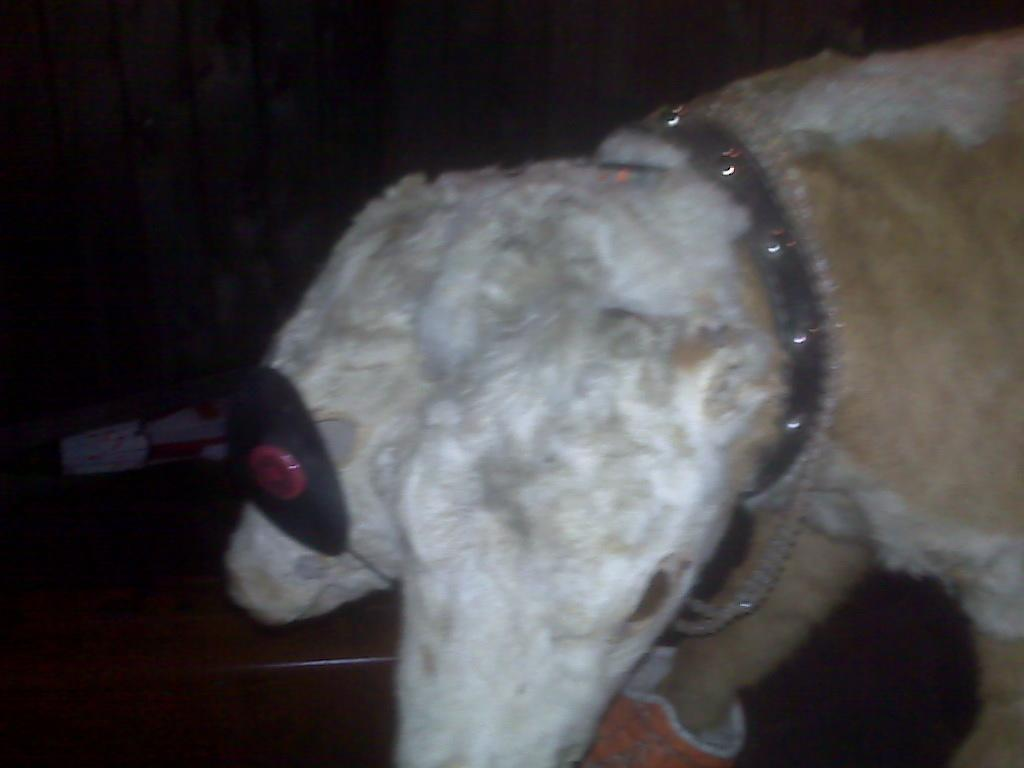How many animals are present in the image? There are two animals in the image. What are the animals doing in the image? The animals are walking on the street. What can be observed about the lighting in the image? The top of the image appears to be dark. What type of honey is being collected by the lizards in the image? There are no lizards or honey present in the image; it features two animals walking on the street. 